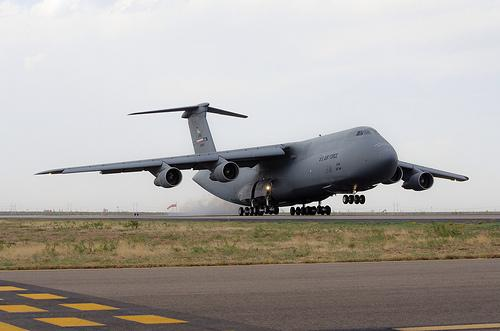Provide a short sentence describing the dominant components in the image. The image prominently displays a large gray airplane during takeoff, with noticeable wings and landing gear, and a cloudy sky in the background. Narrate the scene in the image with a concise description. An airplane is in the process of taking off from a busy airport runway, with a grassy foreground and a backdrop of fluffy clouds in a blue sky. What is the most eye-catching aspect of this image? Describe it briefly. A gray airplane lifting off the ground, with its wing and landing gear prominently visible, captures the viewers' attention. Write a brief description concentrating on the main object in the image and its current state. A large modern airplane is in the process of taking off, with its detailed wings and landing gear on display. Choose the central theme of the image and provide a brief explanation. The image showcases an airplane taking off from a runway with clear blue sky and white clouds in the background. Summarize the most important aspects of the image in one compact sentence. The image highlights a large airplane taking off from a runway, displaying its distinct wing and landing gear features against a cloudy sky backdrop. Mention the primary object in the image and describe the key features around it. The dominant object is a gray airplane during takeoff, surrounded by a runway with yellow stripes, an expansive wing, landing gear, and a blue sky filled with white clouds. Mention the most significant object in the image with a short description of its situation. A large modern airplane is situated on the runway during takeoff, with visible wings and landing gear. In a short sentence, describe the overall atmosphere of the image. The image conveys a sense of motion and excitement, as a modern airplane takes off against a backdrop of a cloudy sky. Describe the main elements presented in the image using a single sentence. The image exhibits a large airplane taking off from the runway, featuring its sizable wings and landing gear, set against a cloudy sky. 